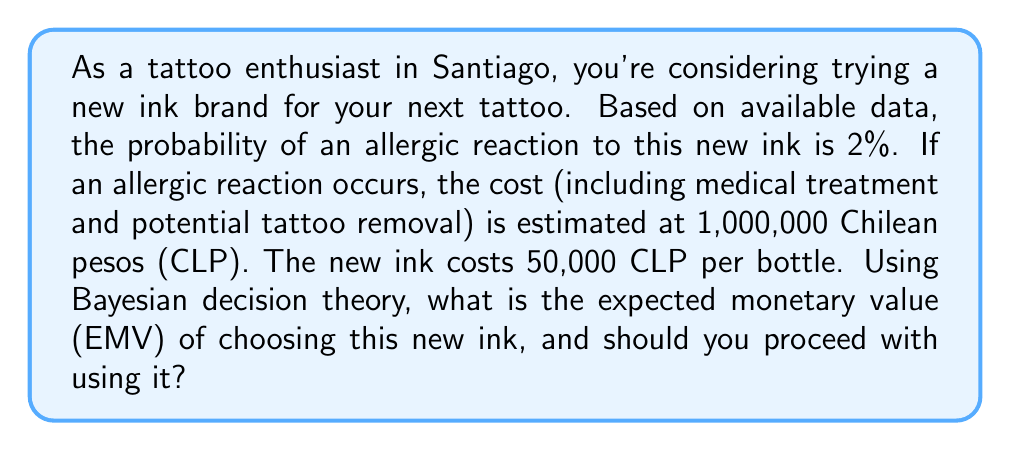Help me with this question. To solve this problem using Bayesian decision theory, we need to calculate the Expected Monetary Value (EMV) of choosing the new ink. The EMV is the sum of each possible outcome multiplied by its probability.

Let's break down the problem:

1. Probability of allergic reaction: $p = 0.02$ (2%)
2. Probability of no allergic reaction: $1 - p = 0.98$ (98%)
3. Cost of allergic reaction: 1,000,000 CLP
4. Cost of ink: 50,000 CLP

We can calculate the EMV as follows:

$$EMV = p \cdot (-1,000,000 - 50,000) + (1-p) \cdot (-50,000)$$

This equation represents:
- The probability of an allergic reaction multiplied by the total cost (reaction cost + ink cost)
- Plus the probability of no reaction multiplied by just the ink cost

Let's substitute the values:

$$EMV = 0.02 \cdot (-1,050,000) + 0.98 \cdot (-50,000)$$

$$EMV = -21,000 - 49,000$$

$$EMV = -70,000 \text{ CLP}$$

The negative EMV indicates an expected loss. To decide whether to proceed, we should compare this to the alternative of not using the new ink (EMV = 0).

Since the EMV of using the new ink (-70,000 CLP) is less than the EMV of not using it (0 CLP), the Bayesian decision theory suggests not to proceed with using the new ink.
Answer: The Expected Monetary Value (EMV) of choosing the new ink is -70,000 CLP. Based on Bayesian decision theory, you should not proceed with using this new ink as the expected loss outweighs the potential benefits. 